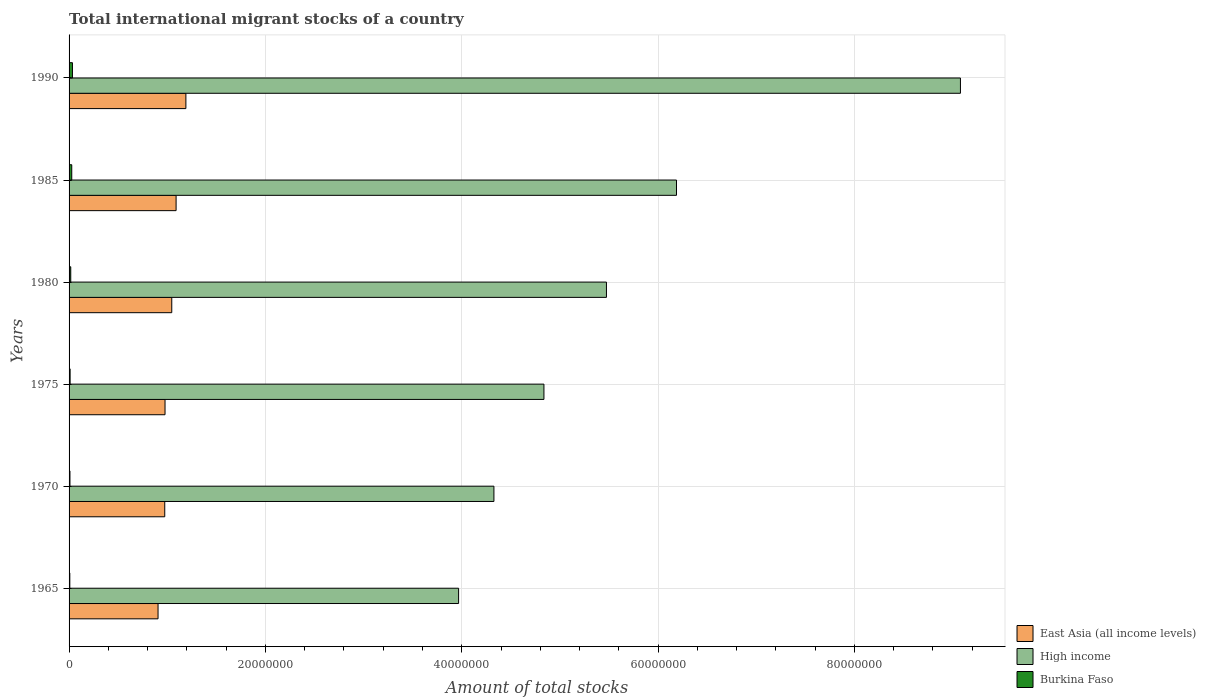How many bars are there on the 1st tick from the top?
Your response must be concise. 3. What is the label of the 6th group of bars from the top?
Ensure brevity in your answer.  1965. What is the amount of total stocks in in High income in 1975?
Your answer should be very brief. 4.84e+07. Across all years, what is the maximum amount of total stocks in in High income?
Offer a very short reply. 9.08e+07. Across all years, what is the minimum amount of total stocks in in Burkina Faso?
Keep it short and to the point. 7.50e+04. In which year was the amount of total stocks in in High income maximum?
Offer a very short reply. 1990. In which year was the amount of total stocks in in High income minimum?
Ensure brevity in your answer.  1965. What is the total amount of total stocks in in High income in the graph?
Offer a very short reply. 3.39e+08. What is the difference between the amount of total stocks in in East Asia (all income levels) in 1965 and that in 1980?
Your answer should be very brief. -1.40e+06. What is the difference between the amount of total stocks in in East Asia (all income levels) in 1970 and the amount of total stocks in in Burkina Faso in 1985?
Your answer should be very brief. 9.47e+06. What is the average amount of total stocks in in Burkina Faso per year?
Make the answer very short. 1.77e+05. In the year 1975, what is the difference between the amount of total stocks in in Burkina Faso and amount of total stocks in in East Asia (all income levels)?
Offer a terse response. -9.67e+06. In how many years, is the amount of total stocks in in High income greater than 52000000 ?
Offer a very short reply. 3. What is the ratio of the amount of total stocks in in Burkina Faso in 1980 to that in 1990?
Offer a very short reply. 0.49. Is the amount of total stocks in in High income in 1970 less than that in 1990?
Provide a short and direct response. Yes. What is the difference between the highest and the second highest amount of total stocks in in High income?
Offer a very short reply. 2.89e+07. What is the difference between the highest and the lowest amount of total stocks in in Burkina Faso?
Your answer should be very brief. 2.70e+05. In how many years, is the amount of total stocks in in East Asia (all income levels) greater than the average amount of total stocks in in East Asia (all income levels) taken over all years?
Offer a very short reply. 3. What does the 2nd bar from the top in 1975 represents?
Offer a terse response. High income. What does the 3rd bar from the bottom in 1965 represents?
Your response must be concise. Burkina Faso. How many bars are there?
Your answer should be compact. 18. How many years are there in the graph?
Offer a very short reply. 6. What is the difference between two consecutive major ticks on the X-axis?
Make the answer very short. 2.00e+07. What is the title of the graph?
Offer a terse response. Total international migrant stocks of a country. What is the label or title of the X-axis?
Your response must be concise. Amount of total stocks. What is the Amount of total stocks of East Asia (all income levels) in 1965?
Give a very brief answer. 9.06e+06. What is the Amount of total stocks in High income in 1965?
Your response must be concise. 3.97e+07. What is the Amount of total stocks in Burkina Faso in 1965?
Your answer should be compact. 7.50e+04. What is the Amount of total stocks in East Asia (all income levels) in 1970?
Keep it short and to the point. 9.75e+06. What is the Amount of total stocks of High income in 1970?
Keep it short and to the point. 4.33e+07. What is the Amount of total stocks of Burkina Faso in 1970?
Make the answer very short. 8.93e+04. What is the Amount of total stocks of East Asia (all income levels) in 1975?
Your response must be concise. 9.77e+06. What is the Amount of total stocks in High income in 1975?
Your answer should be compact. 4.84e+07. What is the Amount of total stocks of Burkina Faso in 1975?
Your answer should be compact. 1.06e+05. What is the Amount of total stocks in East Asia (all income levels) in 1980?
Give a very brief answer. 1.05e+07. What is the Amount of total stocks in High income in 1980?
Provide a succinct answer. 5.47e+07. What is the Amount of total stocks in Burkina Faso in 1980?
Your answer should be very brief. 1.70e+05. What is the Amount of total stocks in East Asia (all income levels) in 1985?
Make the answer very short. 1.09e+07. What is the Amount of total stocks in High income in 1985?
Provide a succinct answer. 6.19e+07. What is the Amount of total stocks in Burkina Faso in 1985?
Make the answer very short. 2.73e+05. What is the Amount of total stocks in East Asia (all income levels) in 1990?
Your response must be concise. 1.19e+07. What is the Amount of total stocks in High income in 1990?
Offer a very short reply. 9.08e+07. What is the Amount of total stocks of Burkina Faso in 1990?
Offer a terse response. 3.45e+05. Across all years, what is the maximum Amount of total stocks in East Asia (all income levels)?
Offer a terse response. 1.19e+07. Across all years, what is the maximum Amount of total stocks in High income?
Offer a very short reply. 9.08e+07. Across all years, what is the maximum Amount of total stocks in Burkina Faso?
Offer a terse response. 3.45e+05. Across all years, what is the minimum Amount of total stocks in East Asia (all income levels)?
Ensure brevity in your answer.  9.06e+06. Across all years, what is the minimum Amount of total stocks in High income?
Your response must be concise. 3.97e+07. Across all years, what is the minimum Amount of total stocks in Burkina Faso?
Ensure brevity in your answer.  7.50e+04. What is the total Amount of total stocks of East Asia (all income levels) in the graph?
Ensure brevity in your answer.  6.18e+07. What is the total Amount of total stocks of High income in the graph?
Keep it short and to the point. 3.39e+08. What is the total Amount of total stocks of Burkina Faso in the graph?
Your response must be concise. 1.06e+06. What is the difference between the Amount of total stocks in East Asia (all income levels) in 1965 and that in 1970?
Your answer should be compact. -6.82e+05. What is the difference between the Amount of total stocks in High income in 1965 and that in 1970?
Provide a succinct answer. -3.60e+06. What is the difference between the Amount of total stocks of Burkina Faso in 1965 and that in 1970?
Your response must be concise. -1.43e+04. What is the difference between the Amount of total stocks in East Asia (all income levels) in 1965 and that in 1975?
Make the answer very short. -7.10e+05. What is the difference between the Amount of total stocks in High income in 1965 and that in 1975?
Your answer should be very brief. -8.69e+06. What is the difference between the Amount of total stocks of Burkina Faso in 1965 and that in 1975?
Give a very brief answer. -3.14e+04. What is the difference between the Amount of total stocks in East Asia (all income levels) in 1965 and that in 1980?
Give a very brief answer. -1.40e+06. What is the difference between the Amount of total stocks of High income in 1965 and that in 1980?
Offer a very short reply. -1.51e+07. What is the difference between the Amount of total stocks of Burkina Faso in 1965 and that in 1980?
Your response must be concise. -9.55e+04. What is the difference between the Amount of total stocks in East Asia (all income levels) in 1965 and that in 1985?
Give a very brief answer. -1.84e+06. What is the difference between the Amount of total stocks of High income in 1965 and that in 1985?
Provide a succinct answer. -2.22e+07. What is the difference between the Amount of total stocks in Burkina Faso in 1965 and that in 1985?
Provide a succinct answer. -1.98e+05. What is the difference between the Amount of total stocks in East Asia (all income levels) in 1965 and that in 1990?
Your response must be concise. -2.84e+06. What is the difference between the Amount of total stocks in High income in 1965 and that in 1990?
Provide a short and direct response. -5.11e+07. What is the difference between the Amount of total stocks in Burkina Faso in 1965 and that in 1990?
Your response must be concise. -2.70e+05. What is the difference between the Amount of total stocks of East Asia (all income levels) in 1970 and that in 1975?
Ensure brevity in your answer.  -2.84e+04. What is the difference between the Amount of total stocks of High income in 1970 and that in 1975?
Offer a very short reply. -5.10e+06. What is the difference between the Amount of total stocks in Burkina Faso in 1970 and that in 1975?
Your answer should be very brief. -1.71e+04. What is the difference between the Amount of total stocks in East Asia (all income levels) in 1970 and that in 1980?
Your answer should be very brief. -7.15e+05. What is the difference between the Amount of total stocks of High income in 1970 and that in 1980?
Provide a short and direct response. -1.15e+07. What is the difference between the Amount of total stocks of Burkina Faso in 1970 and that in 1980?
Offer a terse response. -8.12e+04. What is the difference between the Amount of total stocks in East Asia (all income levels) in 1970 and that in 1985?
Offer a very short reply. -1.16e+06. What is the difference between the Amount of total stocks in High income in 1970 and that in 1985?
Give a very brief answer. -1.86e+07. What is the difference between the Amount of total stocks of Burkina Faso in 1970 and that in 1985?
Ensure brevity in your answer.  -1.84e+05. What is the difference between the Amount of total stocks of East Asia (all income levels) in 1970 and that in 1990?
Offer a very short reply. -2.15e+06. What is the difference between the Amount of total stocks of High income in 1970 and that in 1990?
Give a very brief answer. -4.75e+07. What is the difference between the Amount of total stocks of Burkina Faso in 1970 and that in 1990?
Keep it short and to the point. -2.55e+05. What is the difference between the Amount of total stocks of East Asia (all income levels) in 1975 and that in 1980?
Offer a very short reply. -6.87e+05. What is the difference between the Amount of total stocks of High income in 1975 and that in 1980?
Your response must be concise. -6.37e+06. What is the difference between the Amount of total stocks of Burkina Faso in 1975 and that in 1980?
Provide a succinct answer. -6.41e+04. What is the difference between the Amount of total stocks in East Asia (all income levels) in 1975 and that in 1985?
Offer a terse response. -1.13e+06. What is the difference between the Amount of total stocks in High income in 1975 and that in 1985?
Provide a succinct answer. -1.35e+07. What is the difference between the Amount of total stocks of Burkina Faso in 1975 and that in 1985?
Provide a succinct answer. -1.67e+05. What is the difference between the Amount of total stocks of East Asia (all income levels) in 1975 and that in 1990?
Give a very brief answer. -2.13e+06. What is the difference between the Amount of total stocks in High income in 1975 and that in 1990?
Your response must be concise. -4.24e+07. What is the difference between the Amount of total stocks in Burkina Faso in 1975 and that in 1990?
Provide a succinct answer. -2.38e+05. What is the difference between the Amount of total stocks in East Asia (all income levels) in 1980 and that in 1985?
Provide a short and direct response. -4.40e+05. What is the difference between the Amount of total stocks of High income in 1980 and that in 1985?
Your response must be concise. -7.14e+06. What is the difference between the Amount of total stocks in Burkina Faso in 1980 and that in 1985?
Your answer should be compact. -1.03e+05. What is the difference between the Amount of total stocks in East Asia (all income levels) in 1980 and that in 1990?
Provide a short and direct response. -1.44e+06. What is the difference between the Amount of total stocks in High income in 1980 and that in 1990?
Your answer should be very brief. -3.61e+07. What is the difference between the Amount of total stocks of Burkina Faso in 1980 and that in 1990?
Your answer should be very brief. -1.74e+05. What is the difference between the Amount of total stocks in East Asia (all income levels) in 1985 and that in 1990?
Offer a very short reply. -9.99e+05. What is the difference between the Amount of total stocks of High income in 1985 and that in 1990?
Give a very brief answer. -2.89e+07. What is the difference between the Amount of total stocks of Burkina Faso in 1985 and that in 1990?
Your response must be concise. -7.15e+04. What is the difference between the Amount of total stocks in East Asia (all income levels) in 1965 and the Amount of total stocks in High income in 1970?
Your response must be concise. -3.42e+07. What is the difference between the Amount of total stocks of East Asia (all income levels) in 1965 and the Amount of total stocks of Burkina Faso in 1970?
Make the answer very short. 8.98e+06. What is the difference between the Amount of total stocks of High income in 1965 and the Amount of total stocks of Burkina Faso in 1970?
Your answer should be very brief. 3.96e+07. What is the difference between the Amount of total stocks of East Asia (all income levels) in 1965 and the Amount of total stocks of High income in 1975?
Keep it short and to the point. -3.93e+07. What is the difference between the Amount of total stocks in East Asia (all income levels) in 1965 and the Amount of total stocks in Burkina Faso in 1975?
Provide a succinct answer. 8.96e+06. What is the difference between the Amount of total stocks in High income in 1965 and the Amount of total stocks in Burkina Faso in 1975?
Make the answer very short. 3.96e+07. What is the difference between the Amount of total stocks in East Asia (all income levels) in 1965 and the Amount of total stocks in High income in 1980?
Offer a very short reply. -4.57e+07. What is the difference between the Amount of total stocks of East Asia (all income levels) in 1965 and the Amount of total stocks of Burkina Faso in 1980?
Give a very brief answer. 8.89e+06. What is the difference between the Amount of total stocks in High income in 1965 and the Amount of total stocks in Burkina Faso in 1980?
Offer a terse response. 3.95e+07. What is the difference between the Amount of total stocks of East Asia (all income levels) in 1965 and the Amount of total stocks of High income in 1985?
Offer a very short reply. -5.28e+07. What is the difference between the Amount of total stocks in East Asia (all income levels) in 1965 and the Amount of total stocks in Burkina Faso in 1985?
Provide a succinct answer. 8.79e+06. What is the difference between the Amount of total stocks of High income in 1965 and the Amount of total stocks of Burkina Faso in 1985?
Your response must be concise. 3.94e+07. What is the difference between the Amount of total stocks in East Asia (all income levels) in 1965 and the Amount of total stocks in High income in 1990?
Offer a very short reply. -8.17e+07. What is the difference between the Amount of total stocks of East Asia (all income levels) in 1965 and the Amount of total stocks of Burkina Faso in 1990?
Keep it short and to the point. 8.72e+06. What is the difference between the Amount of total stocks in High income in 1965 and the Amount of total stocks in Burkina Faso in 1990?
Give a very brief answer. 3.93e+07. What is the difference between the Amount of total stocks in East Asia (all income levels) in 1970 and the Amount of total stocks in High income in 1975?
Give a very brief answer. -3.86e+07. What is the difference between the Amount of total stocks of East Asia (all income levels) in 1970 and the Amount of total stocks of Burkina Faso in 1975?
Your answer should be very brief. 9.64e+06. What is the difference between the Amount of total stocks of High income in 1970 and the Amount of total stocks of Burkina Faso in 1975?
Give a very brief answer. 4.32e+07. What is the difference between the Amount of total stocks of East Asia (all income levels) in 1970 and the Amount of total stocks of High income in 1980?
Give a very brief answer. -4.50e+07. What is the difference between the Amount of total stocks in East Asia (all income levels) in 1970 and the Amount of total stocks in Burkina Faso in 1980?
Give a very brief answer. 9.58e+06. What is the difference between the Amount of total stocks in High income in 1970 and the Amount of total stocks in Burkina Faso in 1980?
Your answer should be compact. 4.31e+07. What is the difference between the Amount of total stocks in East Asia (all income levels) in 1970 and the Amount of total stocks in High income in 1985?
Your answer should be compact. -5.21e+07. What is the difference between the Amount of total stocks of East Asia (all income levels) in 1970 and the Amount of total stocks of Burkina Faso in 1985?
Your answer should be compact. 9.47e+06. What is the difference between the Amount of total stocks of High income in 1970 and the Amount of total stocks of Burkina Faso in 1985?
Provide a short and direct response. 4.30e+07. What is the difference between the Amount of total stocks in East Asia (all income levels) in 1970 and the Amount of total stocks in High income in 1990?
Offer a terse response. -8.11e+07. What is the difference between the Amount of total stocks of East Asia (all income levels) in 1970 and the Amount of total stocks of Burkina Faso in 1990?
Keep it short and to the point. 9.40e+06. What is the difference between the Amount of total stocks of High income in 1970 and the Amount of total stocks of Burkina Faso in 1990?
Your response must be concise. 4.29e+07. What is the difference between the Amount of total stocks of East Asia (all income levels) in 1975 and the Amount of total stocks of High income in 1980?
Provide a short and direct response. -4.50e+07. What is the difference between the Amount of total stocks in East Asia (all income levels) in 1975 and the Amount of total stocks in Burkina Faso in 1980?
Make the answer very short. 9.60e+06. What is the difference between the Amount of total stocks of High income in 1975 and the Amount of total stocks of Burkina Faso in 1980?
Your answer should be compact. 4.82e+07. What is the difference between the Amount of total stocks in East Asia (all income levels) in 1975 and the Amount of total stocks in High income in 1985?
Ensure brevity in your answer.  -5.21e+07. What is the difference between the Amount of total stocks in East Asia (all income levels) in 1975 and the Amount of total stocks in Burkina Faso in 1985?
Keep it short and to the point. 9.50e+06. What is the difference between the Amount of total stocks in High income in 1975 and the Amount of total stocks in Burkina Faso in 1985?
Your answer should be very brief. 4.81e+07. What is the difference between the Amount of total stocks of East Asia (all income levels) in 1975 and the Amount of total stocks of High income in 1990?
Your response must be concise. -8.10e+07. What is the difference between the Amount of total stocks in East Asia (all income levels) in 1975 and the Amount of total stocks in Burkina Faso in 1990?
Your answer should be very brief. 9.43e+06. What is the difference between the Amount of total stocks of High income in 1975 and the Amount of total stocks of Burkina Faso in 1990?
Your answer should be compact. 4.80e+07. What is the difference between the Amount of total stocks in East Asia (all income levels) in 1980 and the Amount of total stocks in High income in 1985?
Provide a short and direct response. -5.14e+07. What is the difference between the Amount of total stocks of East Asia (all income levels) in 1980 and the Amount of total stocks of Burkina Faso in 1985?
Provide a short and direct response. 1.02e+07. What is the difference between the Amount of total stocks in High income in 1980 and the Amount of total stocks in Burkina Faso in 1985?
Your answer should be very brief. 5.45e+07. What is the difference between the Amount of total stocks of East Asia (all income levels) in 1980 and the Amount of total stocks of High income in 1990?
Your response must be concise. -8.03e+07. What is the difference between the Amount of total stocks of East Asia (all income levels) in 1980 and the Amount of total stocks of Burkina Faso in 1990?
Offer a terse response. 1.01e+07. What is the difference between the Amount of total stocks of High income in 1980 and the Amount of total stocks of Burkina Faso in 1990?
Your answer should be very brief. 5.44e+07. What is the difference between the Amount of total stocks in East Asia (all income levels) in 1985 and the Amount of total stocks in High income in 1990?
Your response must be concise. -7.99e+07. What is the difference between the Amount of total stocks in East Asia (all income levels) in 1985 and the Amount of total stocks in Burkina Faso in 1990?
Your answer should be compact. 1.06e+07. What is the difference between the Amount of total stocks of High income in 1985 and the Amount of total stocks of Burkina Faso in 1990?
Ensure brevity in your answer.  6.15e+07. What is the average Amount of total stocks of East Asia (all income levels) per year?
Your answer should be very brief. 1.03e+07. What is the average Amount of total stocks of High income per year?
Your response must be concise. 5.65e+07. What is the average Amount of total stocks in Burkina Faso per year?
Your answer should be compact. 1.77e+05. In the year 1965, what is the difference between the Amount of total stocks in East Asia (all income levels) and Amount of total stocks in High income?
Provide a succinct answer. -3.06e+07. In the year 1965, what is the difference between the Amount of total stocks of East Asia (all income levels) and Amount of total stocks of Burkina Faso?
Provide a short and direct response. 8.99e+06. In the year 1965, what is the difference between the Amount of total stocks of High income and Amount of total stocks of Burkina Faso?
Ensure brevity in your answer.  3.96e+07. In the year 1970, what is the difference between the Amount of total stocks in East Asia (all income levels) and Amount of total stocks in High income?
Ensure brevity in your answer.  -3.35e+07. In the year 1970, what is the difference between the Amount of total stocks in East Asia (all income levels) and Amount of total stocks in Burkina Faso?
Keep it short and to the point. 9.66e+06. In the year 1970, what is the difference between the Amount of total stocks in High income and Amount of total stocks in Burkina Faso?
Your response must be concise. 4.32e+07. In the year 1975, what is the difference between the Amount of total stocks of East Asia (all income levels) and Amount of total stocks of High income?
Make the answer very short. -3.86e+07. In the year 1975, what is the difference between the Amount of total stocks of East Asia (all income levels) and Amount of total stocks of Burkina Faso?
Ensure brevity in your answer.  9.67e+06. In the year 1975, what is the difference between the Amount of total stocks in High income and Amount of total stocks in Burkina Faso?
Provide a succinct answer. 4.83e+07. In the year 1980, what is the difference between the Amount of total stocks of East Asia (all income levels) and Amount of total stocks of High income?
Your answer should be very brief. -4.43e+07. In the year 1980, what is the difference between the Amount of total stocks in East Asia (all income levels) and Amount of total stocks in Burkina Faso?
Make the answer very short. 1.03e+07. In the year 1980, what is the difference between the Amount of total stocks in High income and Amount of total stocks in Burkina Faso?
Provide a short and direct response. 5.46e+07. In the year 1985, what is the difference between the Amount of total stocks of East Asia (all income levels) and Amount of total stocks of High income?
Make the answer very short. -5.10e+07. In the year 1985, what is the difference between the Amount of total stocks of East Asia (all income levels) and Amount of total stocks of Burkina Faso?
Your answer should be compact. 1.06e+07. In the year 1985, what is the difference between the Amount of total stocks in High income and Amount of total stocks in Burkina Faso?
Offer a terse response. 6.16e+07. In the year 1990, what is the difference between the Amount of total stocks in East Asia (all income levels) and Amount of total stocks in High income?
Your answer should be compact. -7.89e+07. In the year 1990, what is the difference between the Amount of total stocks of East Asia (all income levels) and Amount of total stocks of Burkina Faso?
Your response must be concise. 1.16e+07. In the year 1990, what is the difference between the Amount of total stocks of High income and Amount of total stocks of Burkina Faso?
Ensure brevity in your answer.  9.05e+07. What is the ratio of the Amount of total stocks of East Asia (all income levels) in 1965 to that in 1970?
Your answer should be compact. 0.93. What is the ratio of the Amount of total stocks in High income in 1965 to that in 1970?
Keep it short and to the point. 0.92. What is the ratio of the Amount of total stocks of Burkina Faso in 1965 to that in 1970?
Ensure brevity in your answer.  0.84. What is the ratio of the Amount of total stocks of East Asia (all income levels) in 1965 to that in 1975?
Provide a succinct answer. 0.93. What is the ratio of the Amount of total stocks of High income in 1965 to that in 1975?
Provide a succinct answer. 0.82. What is the ratio of the Amount of total stocks in Burkina Faso in 1965 to that in 1975?
Provide a short and direct response. 0.7. What is the ratio of the Amount of total stocks of East Asia (all income levels) in 1965 to that in 1980?
Ensure brevity in your answer.  0.87. What is the ratio of the Amount of total stocks in High income in 1965 to that in 1980?
Your response must be concise. 0.72. What is the ratio of the Amount of total stocks of Burkina Faso in 1965 to that in 1980?
Keep it short and to the point. 0.44. What is the ratio of the Amount of total stocks of East Asia (all income levels) in 1965 to that in 1985?
Provide a short and direct response. 0.83. What is the ratio of the Amount of total stocks in High income in 1965 to that in 1985?
Keep it short and to the point. 0.64. What is the ratio of the Amount of total stocks in Burkina Faso in 1965 to that in 1985?
Keep it short and to the point. 0.27. What is the ratio of the Amount of total stocks in East Asia (all income levels) in 1965 to that in 1990?
Your response must be concise. 0.76. What is the ratio of the Amount of total stocks of High income in 1965 to that in 1990?
Your answer should be compact. 0.44. What is the ratio of the Amount of total stocks in Burkina Faso in 1965 to that in 1990?
Keep it short and to the point. 0.22. What is the ratio of the Amount of total stocks of East Asia (all income levels) in 1970 to that in 1975?
Give a very brief answer. 1. What is the ratio of the Amount of total stocks in High income in 1970 to that in 1975?
Offer a very short reply. 0.89. What is the ratio of the Amount of total stocks of Burkina Faso in 1970 to that in 1975?
Offer a very short reply. 0.84. What is the ratio of the Amount of total stocks of East Asia (all income levels) in 1970 to that in 1980?
Provide a succinct answer. 0.93. What is the ratio of the Amount of total stocks in High income in 1970 to that in 1980?
Your answer should be compact. 0.79. What is the ratio of the Amount of total stocks in Burkina Faso in 1970 to that in 1980?
Your response must be concise. 0.52. What is the ratio of the Amount of total stocks of East Asia (all income levels) in 1970 to that in 1985?
Offer a terse response. 0.89. What is the ratio of the Amount of total stocks in High income in 1970 to that in 1985?
Provide a succinct answer. 0.7. What is the ratio of the Amount of total stocks of Burkina Faso in 1970 to that in 1985?
Provide a succinct answer. 0.33. What is the ratio of the Amount of total stocks of East Asia (all income levels) in 1970 to that in 1990?
Provide a succinct answer. 0.82. What is the ratio of the Amount of total stocks in High income in 1970 to that in 1990?
Keep it short and to the point. 0.48. What is the ratio of the Amount of total stocks of Burkina Faso in 1970 to that in 1990?
Offer a terse response. 0.26. What is the ratio of the Amount of total stocks of East Asia (all income levels) in 1975 to that in 1980?
Give a very brief answer. 0.93. What is the ratio of the Amount of total stocks of High income in 1975 to that in 1980?
Provide a short and direct response. 0.88. What is the ratio of the Amount of total stocks of Burkina Faso in 1975 to that in 1980?
Make the answer very short. 0.62. What is the ratio of the Amount of total stocks of East Asia (all income levels) in 1975 to that in 1985?
Offer a very short reply. 0.9. What is the ratio of the Amount of total stocks in High income in 1975 to that in 1985?
Keep it short and to the point. 0.78. What is the ratio of the Amount of total stocks of Burkina Faso in 1975 to that in 1985?
Make the answer very short. 0.39. What is the ratio of the Amount of total stocks of East Asia (all income levels) in 1975 to that in 1990?
Ensure brevity in your answer.  0.82. What is the ratio of the Amount of total stocks of High income in 1975 to that in 1990?
Make the answer very short. 0.53. What is the ratio of the Amount of total stocks of Burkina Faso in 1975 to that in 1990?
Your answer should be very brief. 0.31. What is the ratio of the Amount of total stocks of East Asia (all income levels) in 1980 to that in 1985?
Give a very brief answer. 0.96. What is the ratio of the Amount of total stocks in High income in 1980 to that in 1985?
Provide a short and direct response. 0.88. What is the ratio of the Amount of total stocks in Burkina Faso in 1980 to that in 1985?
Your answer should be compact. 0.62. What is the ratio of the Amount of total stocks of East Asia (all income levels) in 1980 to that in 1990?
Ensure brevity in your answer.  0.88. What is the ratio of the Amount of total stocks in High income in 1980 to that in 1990?
Offer a very short reply. 0.6. What is the ratio of the Amount of total stocks of Burkina Faso in 1980 to that in 1990?
Provide a succinct answer. 0.49. What is the ratio of the Amount of total stocks in East Asia (all income levels) in 1985 to that in 1990?
Offer a very short reply. 0.92. What is the ratio of the Amount of total stocks of High income in 1985 to that in 1990?
Offer a terse response. 0.68. What is the ratio of the Amount of total stocks in Burkina Faso in 1985 to that in 1990?
Offer a terse response. 0.79. What is the difference between the highest and the second highest Amount of total stocks in East Asia (all income levels)?
Keep it short and to the point. 9.99e+05. What is the difference between the highest and the second highest Amount of total stocks of High income?
Offer a terse response. 2.89e+07. What is the difference between the highest and the second highest Amount of total stocks in Burkina Faso?
Provide a succinct answer. 7.15e+04. What is the difference between the highest and the lowest Amount of total stocks of East Asia (all income levels)?
Give a very brief answer. 2.84e+06. What is the difference between the highest and the lowest Amount of total stocks of High income?
Give a very brief answer. 5.11e+07. What is the difference between the highest and the lowest Amount of total stocks of Burkina Faso?
Keep it short and to the point. 2.70e+05. 